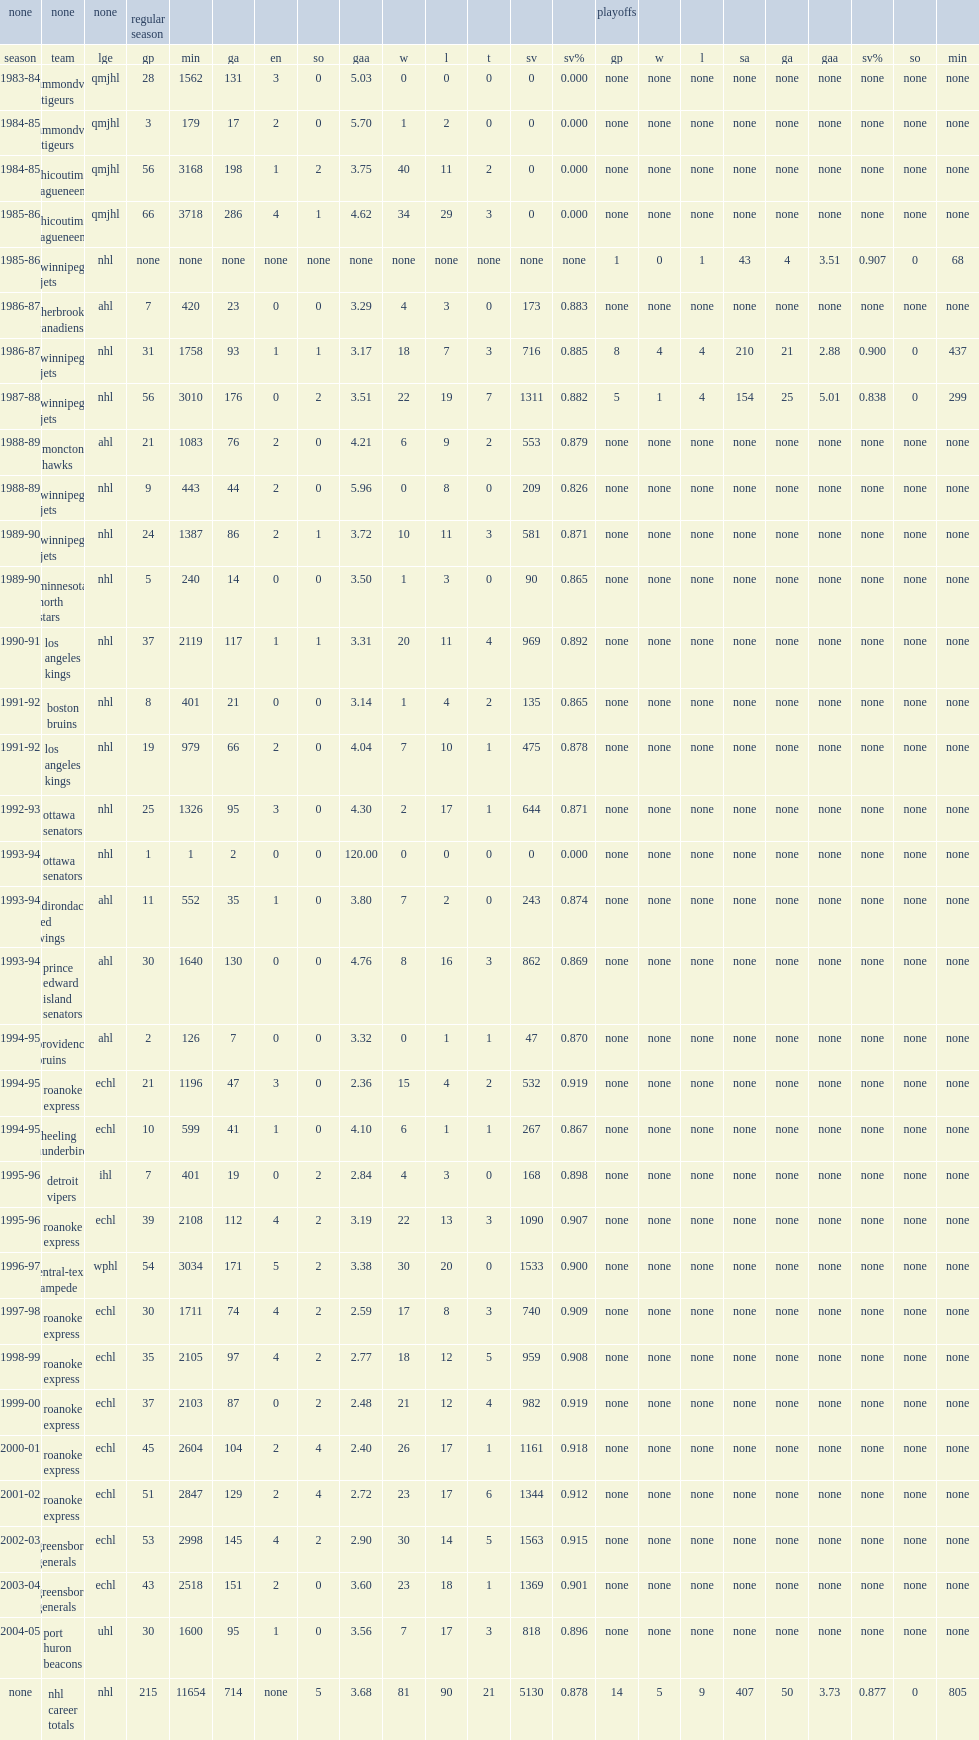How many regular season nhl games did berthiaume play during his career? 215.0. 